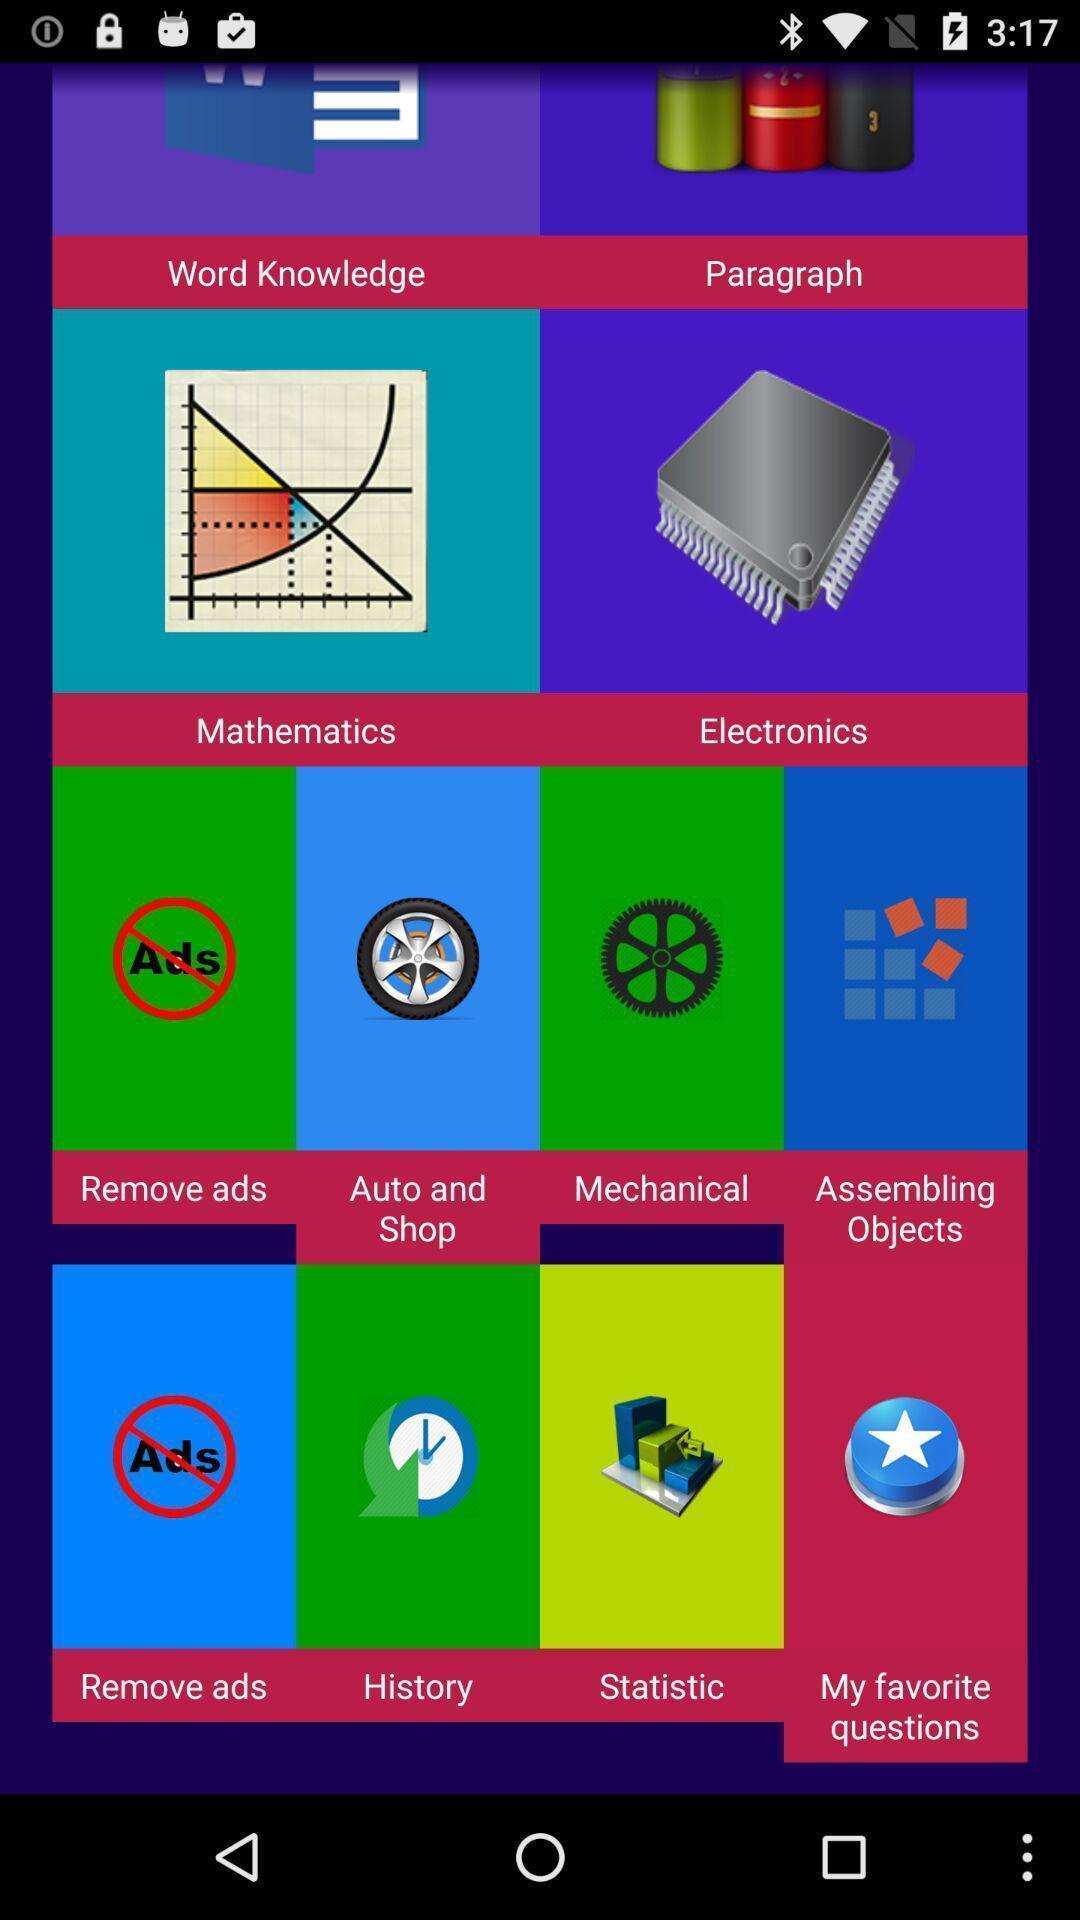Tell me about the visual elements in this screen capture. Screen shows a list of categories from a test app. 